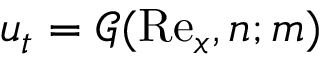Convert formula to latex. <formula><loc_0><loc_0><loc_500><loc_500>u _ { t } = \mathcal { G } ( R e _ { x } , n ; m )</formula> 